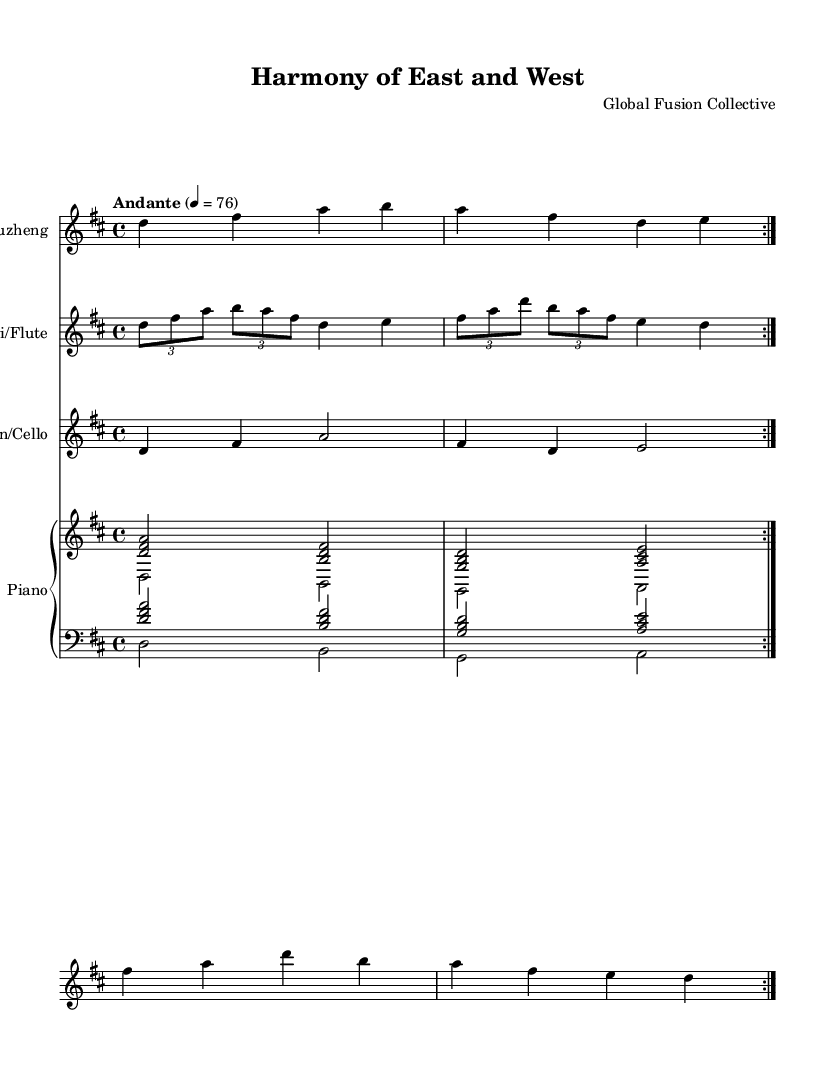What is the key signature of this music? The key signature is D major, which involves two sharps (F# and C#). This can be identified by looking at the beginning of the staff where the sharps are placed.
Answer: D major What is the time signature of this music? The time signature is 4/4, indicated at the beginning of the staff, showing that there are four beats in a measure and the quarter note gets the beat.
Answer: 4/4 What is the tempo marking? The tempo marking indicates "Andante," which describes the desired speed of the piece. This marking appears above the staff and is typically associated with a moderately slow tempo.
Answer: Andante How many total measures are repeated in the erhu/guzheng part? The erhu/guzheng part contains a total of four measures that are repeated twice as indicated by the volta markings. Each volta includes the same four measures.
Answer: Four What instruments are included in this composition? The composition includes four instruments: Erhu/Guzheng, Dizi/Flute, Violin/Cello, and Piano. Each instrument part is specified on its own staff within the score.
Answer: Erhu/Guzheng, Dizi/Flute, Violin/Cello, Piano Which instruments have a tuplet in their part? The Dizi/Flute part features tuples as indicated by the notation using the tuplet symbol, showing a division of beats into smaller note values within the measures.
Answer: Dizi/Flute What is the harmony used in the left hand of the piano? The harmony in the left hand of the piano consists of the notes D, B, G, and A. It is described in the score by the note combinations written as chords.
Answer: D, B, G, A 